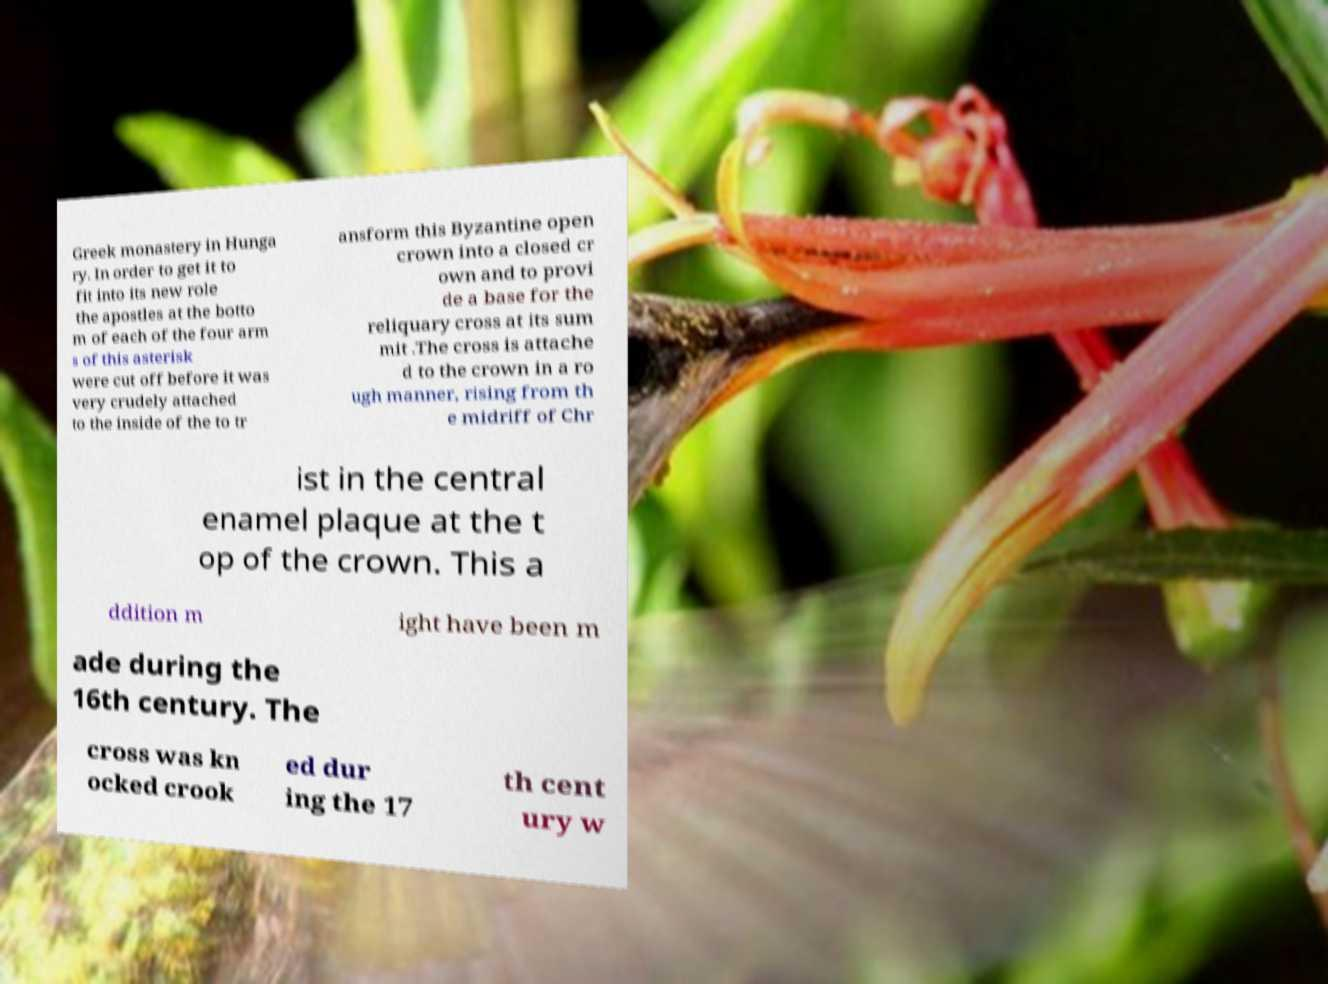Please identify and transcribe the text found in this image. Greek monastery in Hunga ry. In order to get it to fit into its new role the apostles at the botto m of each of the four arm s of this asterisk were cut off before it was very crudely attached to the inside of the to tr ansform this Byzantine open crown into a closed cr own and to provi de a base for the reliquary cross at its sum mit .The cross is attache d to the crown in a ro ugh manner, rising from th e midriff of Chr ist in the central enamel plaque at the t op of the crown. This a ddition m ight have been m ade during the 16th century. The cross was kn ocked crook ed dur ing the 17 th cent ury w 